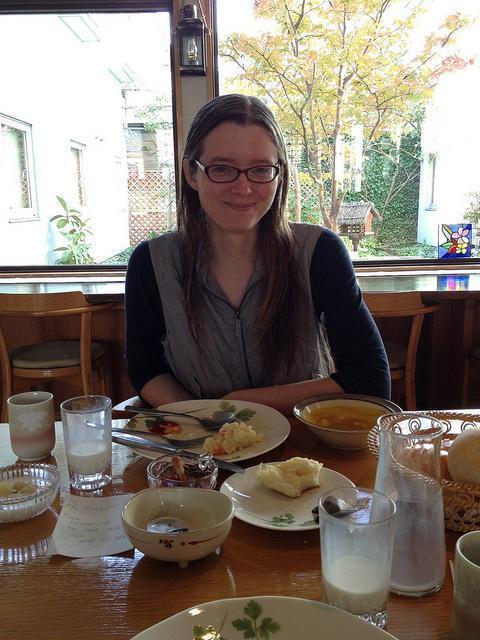How many people are likely enjoying this meal?
Indicate the correct choice and explain in the format: 'Answer: answer
Rationale: rationale.'
Options: Two, seven, 12, 14. Answer: two.
Rationale: There are 2. 